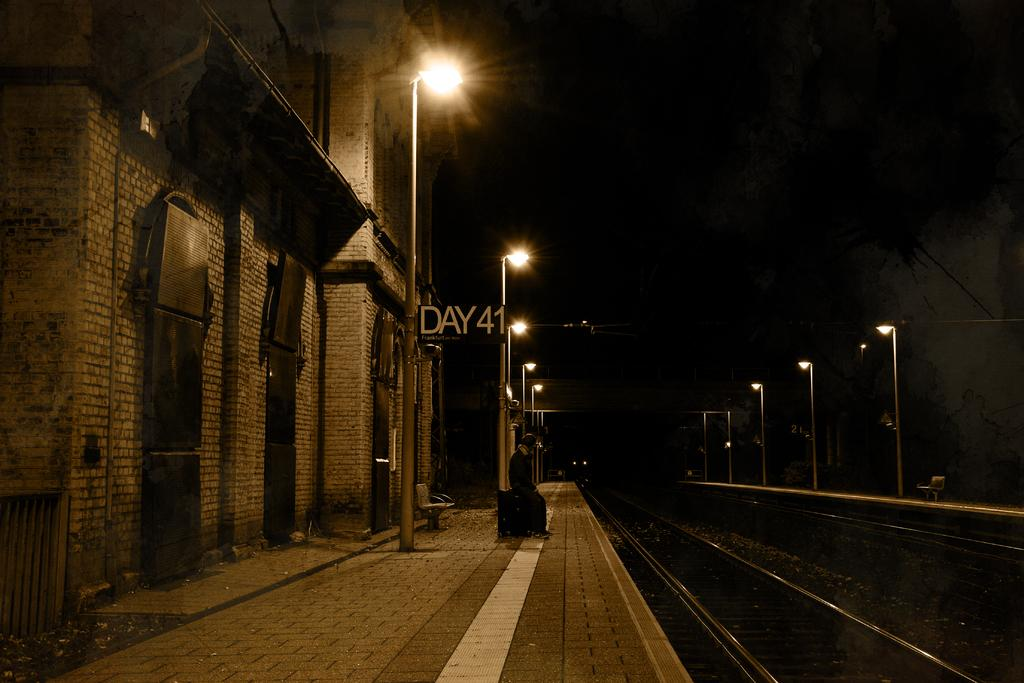<image>
Offer a succinct explanation of the picture presented. A man sitting on a suitcase in front of a Day 41 Frankfurt am Maim sign 